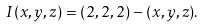<formula> <loc_0><loc_0><loc_500><loc_500>I ( x , y , z ) = ( 2 , 2 , 2 ) - ( x , y , z ) .</formula> 